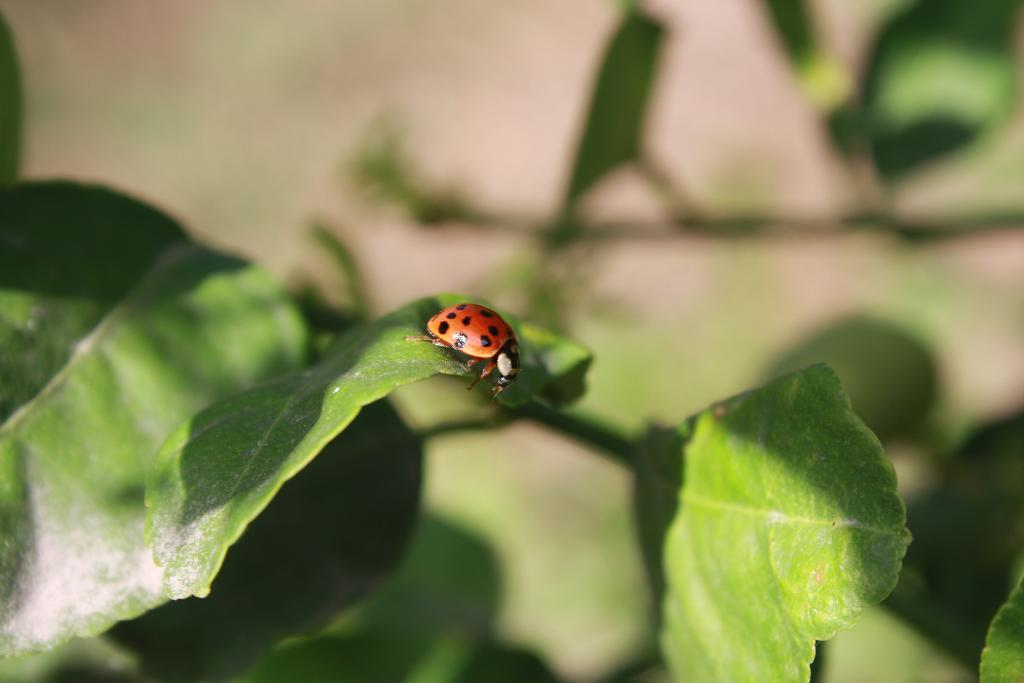What type of living organisms can be seen in the image? Plants can be seen in the image. Can you describe any specific details about the plants? There is an insect on one of the leaves. What can be observed about the background of the image? The background of the image is blurred. What type of drug can be seen in the image? There is no drug present in the image; it features plants and an insect on a leaf. 